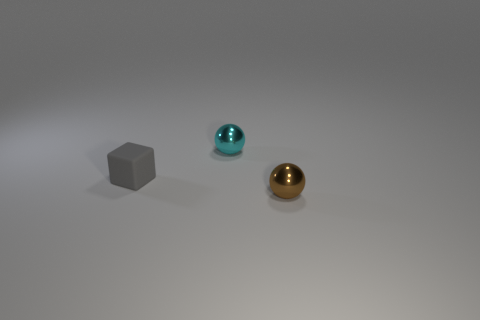There is another metal thing that is the same shape as the cyan shiny object; what color is it? The other object that shares the same spherical shape as the cyan object is a lustrous golden hue. 